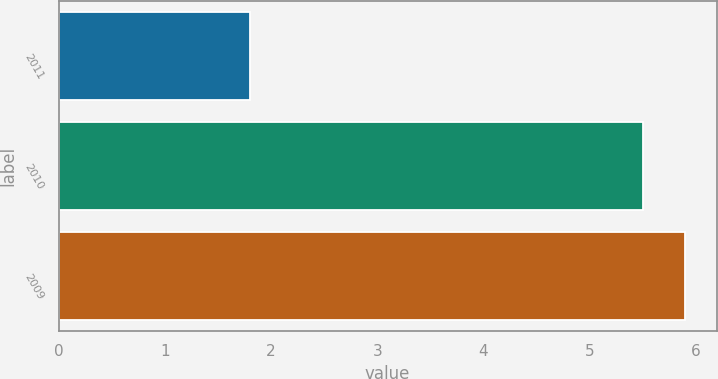Convert chart to OTSL. <chart><loc_0><loc_0><loc_500><loc_500><bar_chart><fcel>2011<fcel>2010<fcel>2009<nl><fcel>1.8<fcel>5.5<fcel>5.9<nl></chart> 